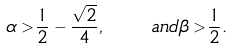Convert formula to latex. <formula><loc_0><loc_0><loc_500><loc_500>\alpha > \frac { 1 } { 2 } - \frac { \sqrt { 2 } } { 4 } , \quad a n d \beta > \frac { 1 } { 2 } .</formula> 